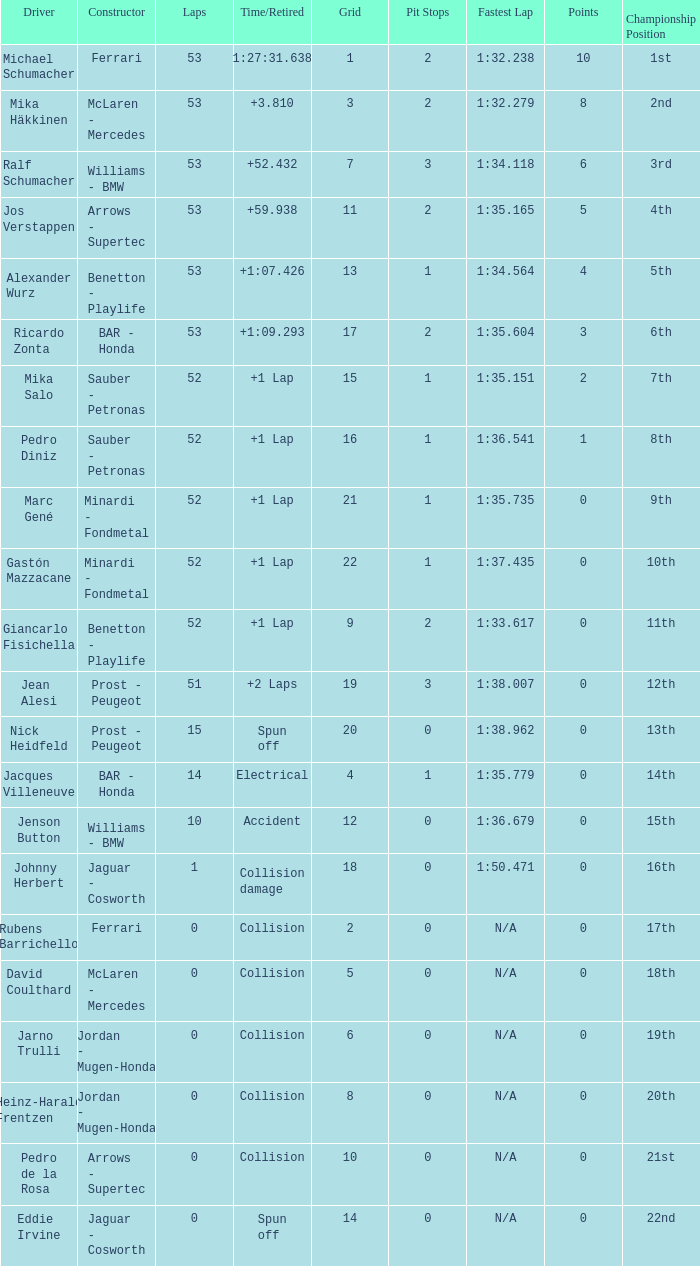What is the average Laps for a grid smaller than 17, and a Constructor of williams - bmw, driven by jenson button? 10.0. 